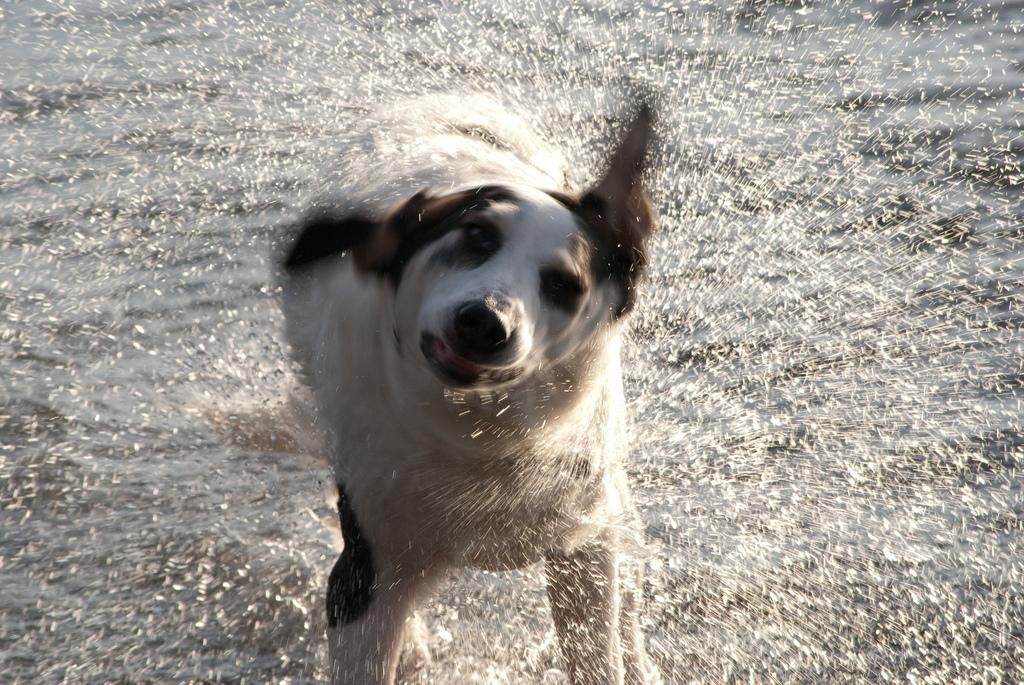What type of animal is in the image? The type of animal cannot be determined from the provided facts. What is the primary element visible in the image? Water is the primary element visible in the image. Can you describe the appearance of the water in the image? Water droplets are present in the image. What type of feast is being prepared in the image? There is no indication of a feast or any food preparation in the image. What process is being depicted in the image? The image does not depict a specific process; it primarily features water and water droplets. 